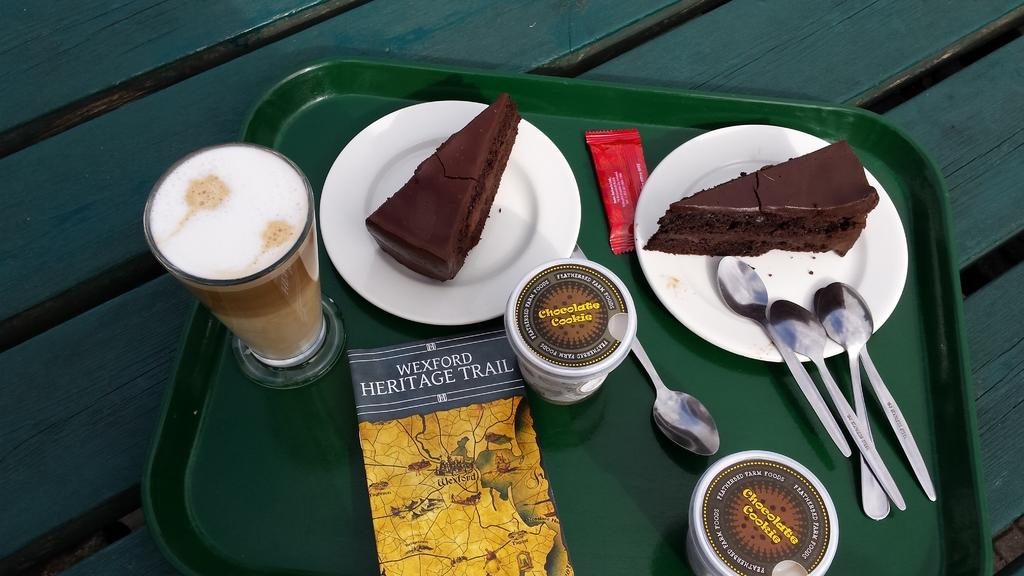What type of utensils are visible in the image? There are spoons in the image. What type of containers are visible in the image? There are cups in the image. What type of beverage is visible in the image? There is a glass of coffee in the image. What type of reading material is visible in the image? There is a book in the image. What type of packaging is visible in the image? There is a packet in the image. What type of dessert is visible in the image? There are two cake slices on plates in the image. How are the objects arranged in the image? The objects are on a tray in the image, and the tray is on a wooden board in the image. What type of jeans is visible in the image? There are no jeans present in the image. What type of steam is coming off the coffee in the image? There is no steam visible in the image; the coffee appears to be at room temperature. 